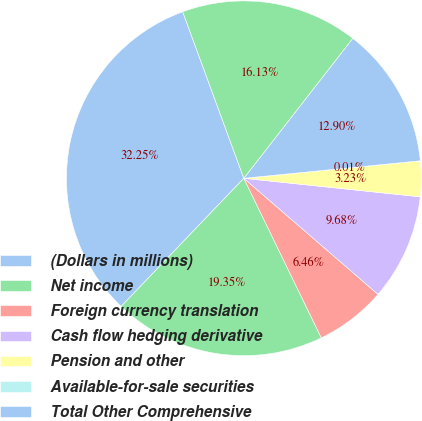<chart> <loc_0><loc_0><loc_500><loc_500><pie_chart><fcel>(Dollars in millions)<fcel>Net income<fcel>Foreign currency translation<fcel>Cash flow hedging derivative<fcel>Pension and other<fcel>Available-for-sale securities<fcel>Total Other Comprehensive<fcel>Comprehensive Income<nl><fcel>32.25%<fcel>19.35%<fcel>6.46%<fcel>9.68%<fcel>3.23%<fcel>0.01%<fcel>12.9%<fcel>16.13%<nl></chart> 